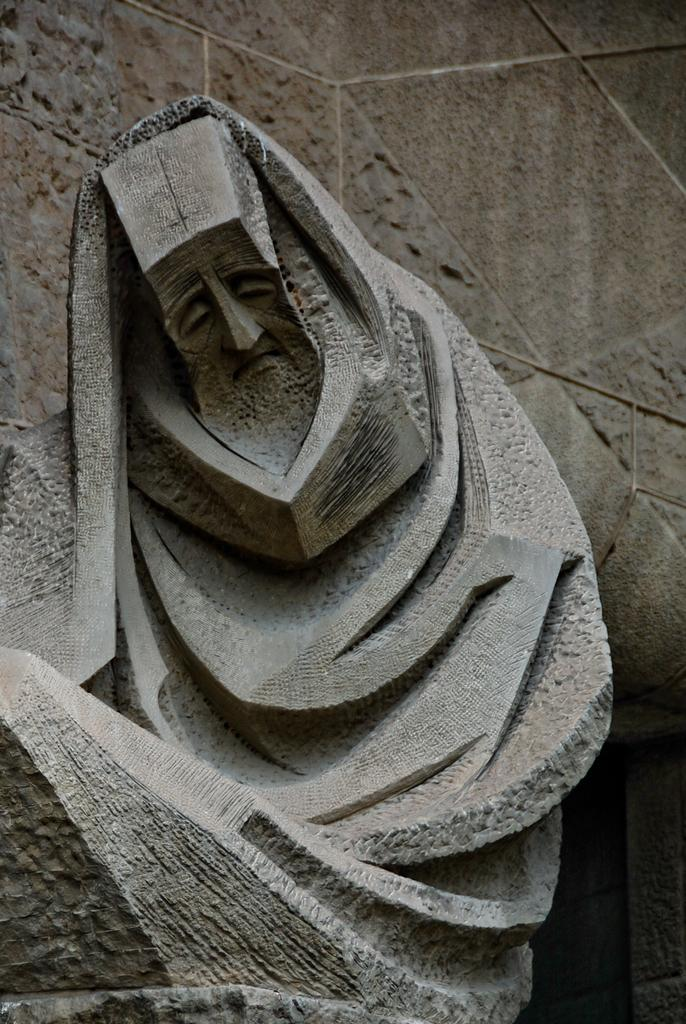What is the main subject in the center of the image? There is a sculpture in the center of the image. What can be seen in the background of the image? There is a wall in the background of the image. How many boys are wearing dresses in the image? There are no boys or dresses present in the image. 